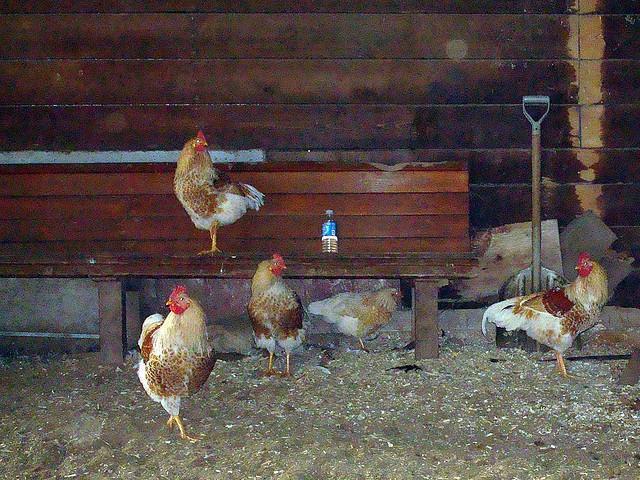How many chickens are there with redheads?
Give a very brief answer. 4. How many birds are in the picture?
Give a very brief answer. 5. How many benches are there?
Give a very brief answer. 1. 